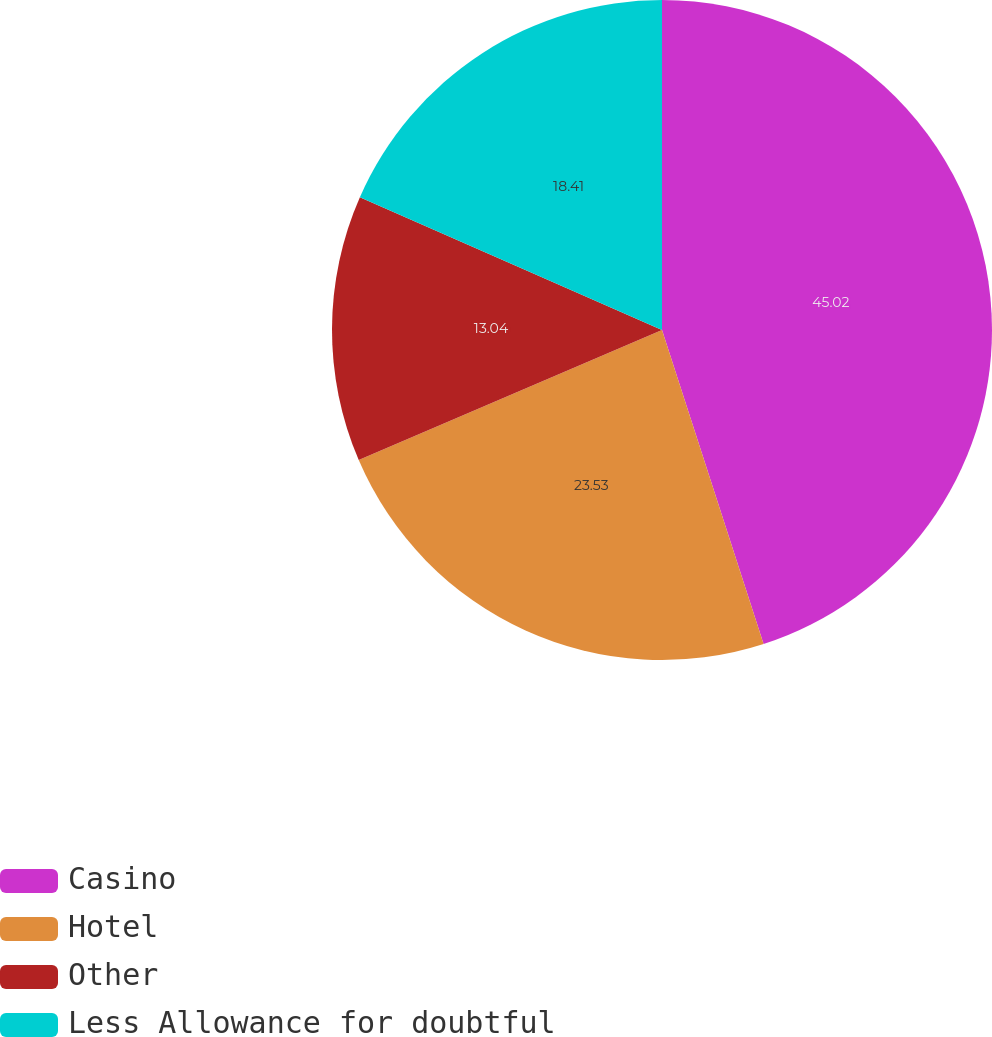Convert chart. <chart><loc_0><loc_0><loc_500><loc_500><pie_chart><fcel>Casino<fcel>Hotel<fcel>Other<fcel>Less Allowance for doubtful<nl><fcel>45.02%<fcel>23.53%<fcel>13.04%<fcel>18.41%<nl></chart> 